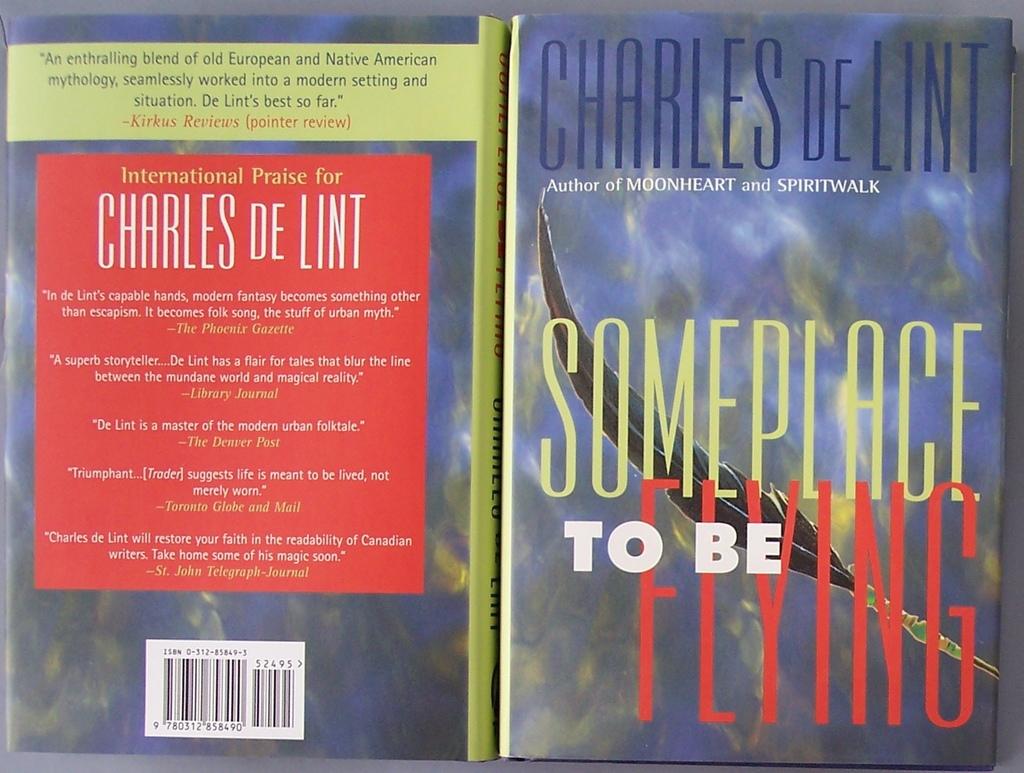What is the title of the book?
Give a very brief answer. Someplace to be flying. 